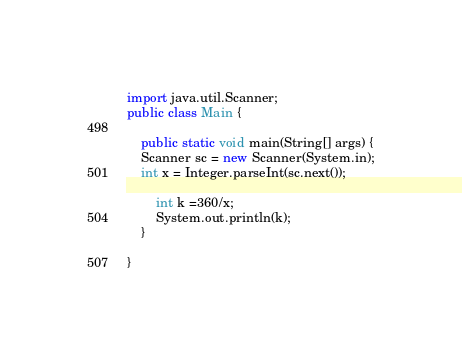Convert code to text. <code><loc_0><loc_0><loc_500><loc_500><_Java_>import java.util.Scanner;
public class Main {

    public static void main(String[] args) {
    Scanner sc = new Scanner(System.in);
	int x = Integer.parseInt(sc.next());
		
		int k =360/x;      
		System.out.println(k);
    }

}</code> 